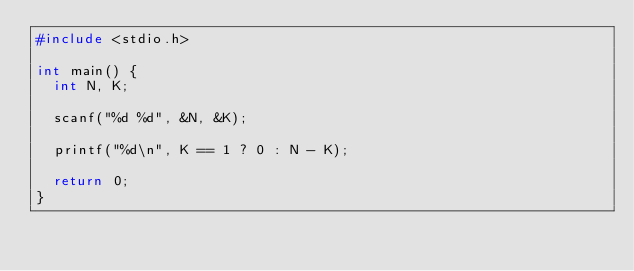Convert code to text. <code><loc_0><loc_0><loc_500><loc_500><_C_>#include <stdio.h>

int main() {
	int N, K;

	scanf("%d %d", &N, &K);

	printf("%d\n", K == 1 ? 0 : N - K);

	return 0;
}</code> 